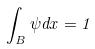Convert formula to latex. <formula><loc_0><loc_0><loc_500><loc_500>\int _ { B } \psi d x = 1</formula> 